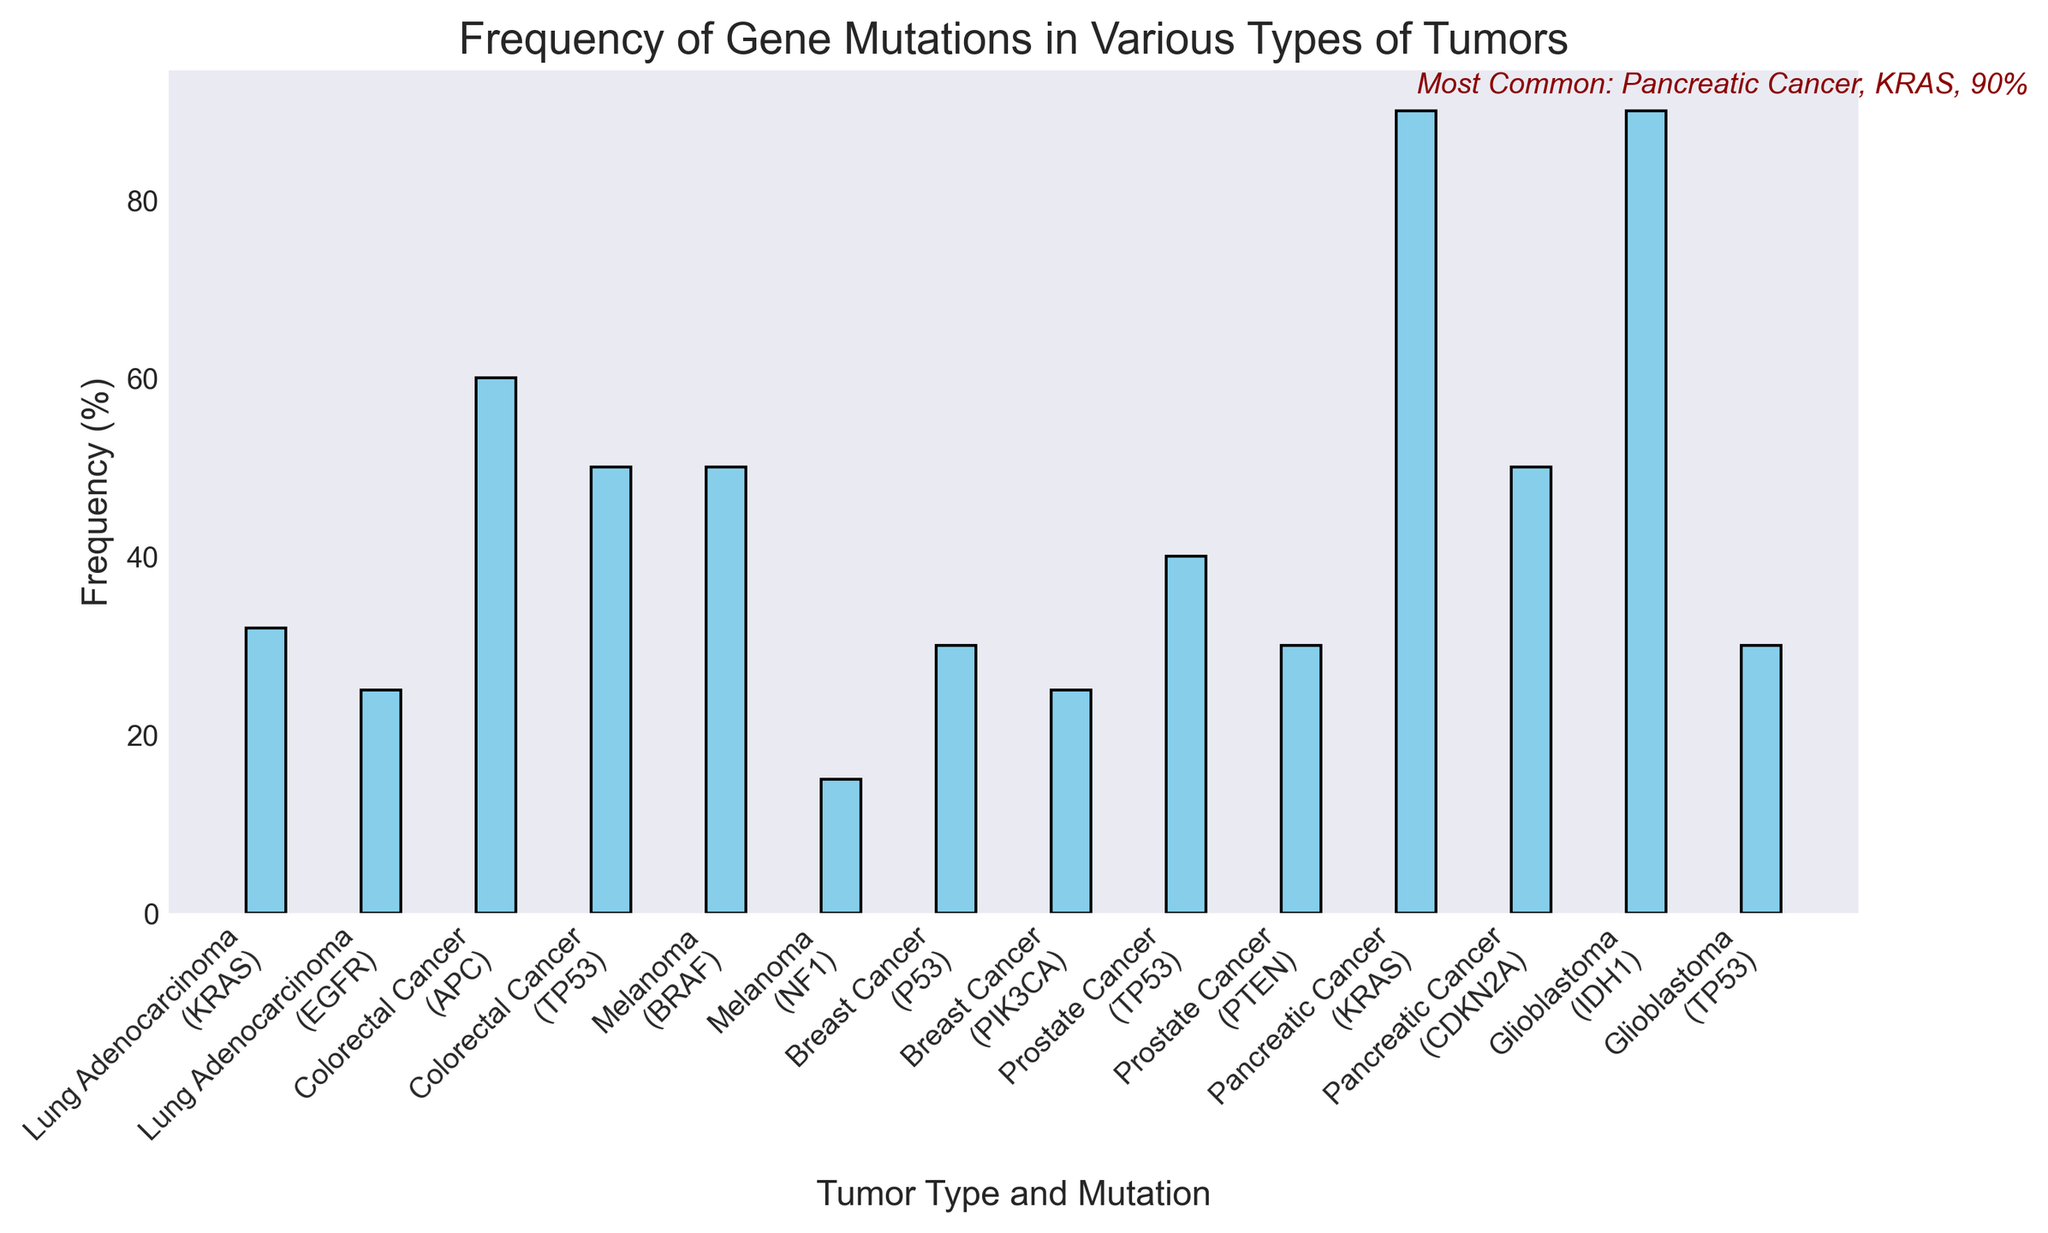Which tumor type and gene mutation have the highest frequency? To find this, look for the bar that reaches the highest percentage on the y-axis. According to the annotation, the most common mutation is with Glioblastoma and IDH1 at 90%.
Answer: Glioblastoma, IDH1, 90% Which tumor type and gene mutation have the lowest frequency, and what is the percentage? To determine the lowest frequency, scan the bars and find the shortest one, which corresponds to the lowest value. The bar with the lowest frequency points to NF1 in Melanoma at 15%.
Answer: Melanoma, NF1, 15% What is the difference in frequency between the mutations in Lung Adenocarcinoma? To find the difference, subtract the lower frequency mutation from the higher one. KRAS is at 32%, and EGFR is at 25% for Lung Adenocarcinoma. The difference is 32% - 25% = 7%.
Answer: 7% Compare the frequency of TP53 mutations in Colorectal Cancer and Prostate Cancer. Which tumor type has a higher frequency and by how much? Look specifically at the height of the bars for TP53 in both tumor types. Colorectal Cancer has 50% and Prostate Cancer has 40%. The difference is 10%.
Answer: Colorectal Cancer, by 10% What is the average frequency of the gene mutations listed for Breast Cancer? Calculate the average by adding the frequencies of P53 and PIK3CA (30% + 25%) and then dividing by the number of mutations (2). The calculation is (30% + 25%) / 2 = 27.5%.
Answer: 27.5% Which tumor type has the same frequency for both of its gene mutations, and what is that frequency? Identify if there are any pairs of bars for one tumor type that are equal in height or percentage. Glioblastoma has both IDH1 and TP53, but the frequencies differ (90% and 30%). No tumor type has the same frequency for both mutations.
Answer: None Compare the visual lengths of the bars representing KRAS mutations in Lung Adenocarcinoma and Pancreatic Cancer. Which tumor type has a longer bar and what is the percentage? Visually identify and compare the two bars representing KRAS mutations. The bar for Pancreatic Cancer is longer with a percentage of 90%, while Lung Adenocarcinoma is at 32%.
Answer: Pancreatic Cancer, 90% Arrange the tumor types in ascending order of their highest gene mutation frequency. Identify the highest frequency for each tumor type and then arrange these frequencies in ascending order: Melanoma (50%), Prostate Cancer (40%), Breast Cancer (30%), Lung Adenocarcinoma (32%), Colorectal Cancer (60%), Glioblastoma (90%), Pancreatic Cancer (90%)
Answer: Lung Adenocarcinoma, Breast Cancer, Prostate Cancer, Melanoma, Colorectal Cancer, Glioblastoma, Pancreatic Cancer 